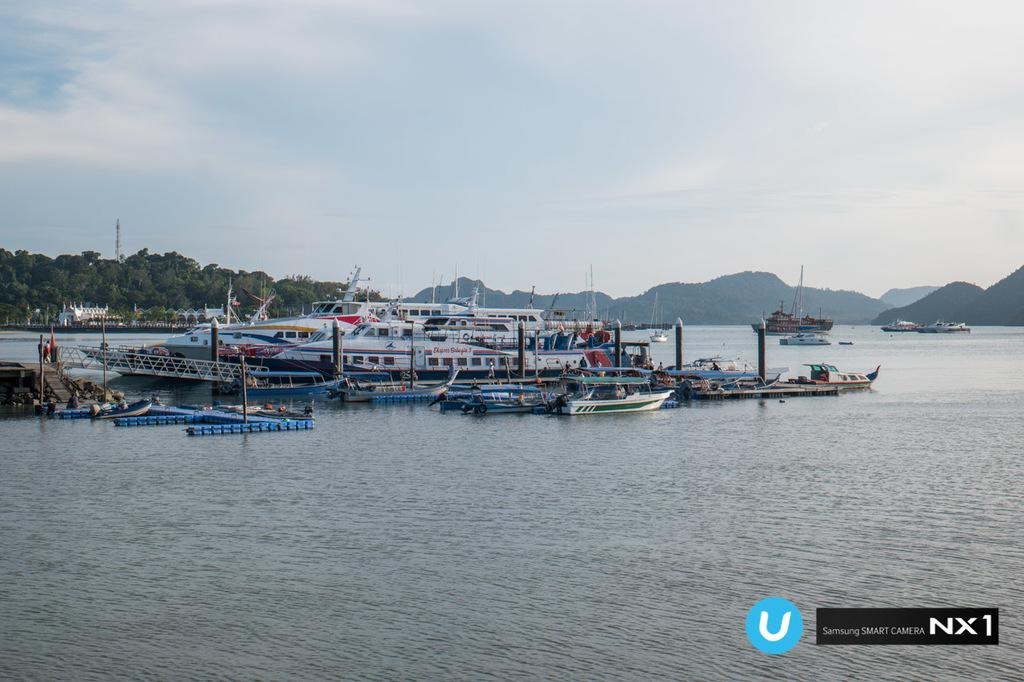What types of watercraft are present in the image? There are ships and boats in the image. What is the primary setting for the watercraft? There is water visible in the image. What other elements can be seen in the image? There are trees, buildings, a tower, hills, and the sky visible in the image. What is the condition of the sky in the image? The sky is visible in the image, and there are clouds present. Where is the mom in the image? There is no mom present in the image. What type of mitten is being used by the person in the image? There is no person or mitten present in the image. 